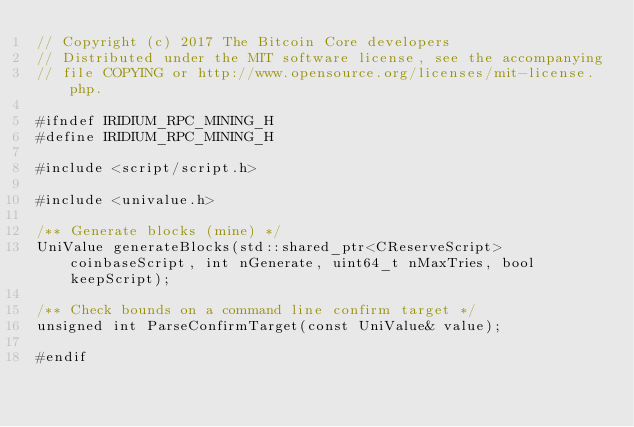<code> <loc_0><loc_0><loc_500><loc_500><_C_>// Copyright (c) 2017 The Bitcoin Core developers
// Distributed under the MIT software license, see the accompanying
// file COPYING or http://www.opensource.org/licenses/mit-license.php.

#ifndef IRIDIUM_RPC_MINING_H
#define IRIDIUM_RPC_MINING_H

#include <script/script.h>

#include <univalue.h>

/** Generate blocks (mine) */
UniValue generateBlocks(std::shared_ptr<CReserveScript> coinbaseScript, int nGenerate, uint64_t nMaxTries, bool keepScript);

/** Check bounds on a command line confirm target */
unsigned int ParseConfirmTarget(const UniValue& value);

#endif
</code> 